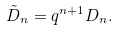<formula> <loc_0><loc_0><loc_500><loc_500>\tilde { D } _ { n } = q ^ { n + 1 } D _ { n } .</formula> 